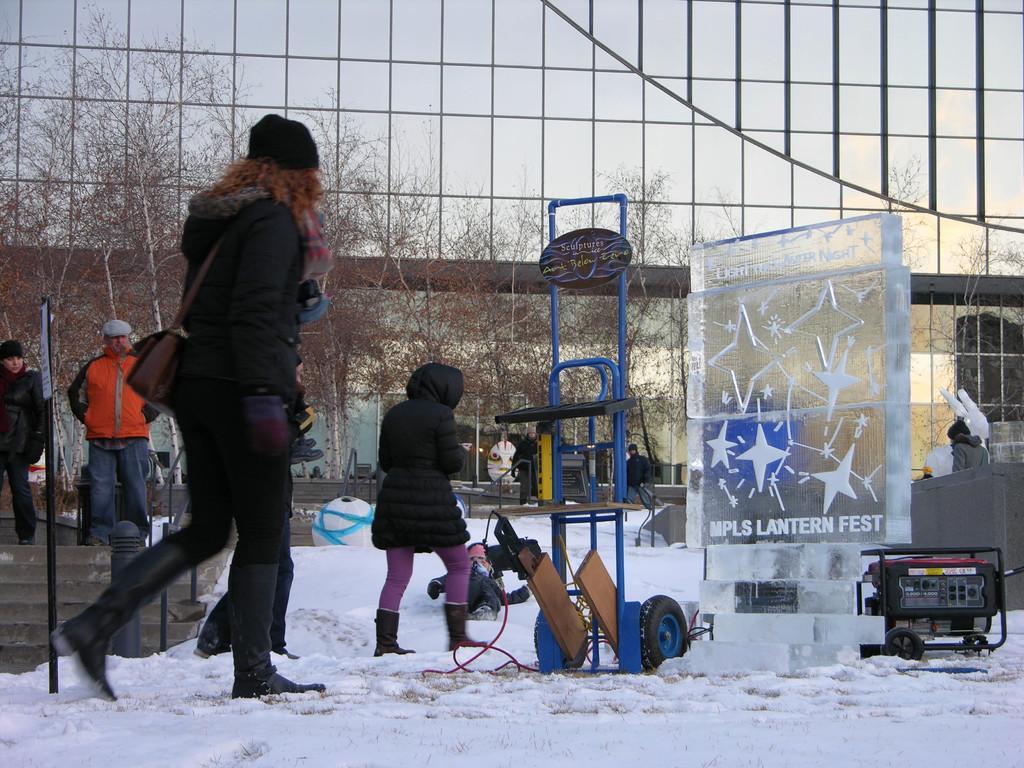How would you summarize this image in a sentence or two? In front of the image there are people walking on the snow. There are some objects on the surface. There is a board with some text and drawing on it. On the left side of the image there are stairs, poles. In the background of the image there are trees and buildings. 